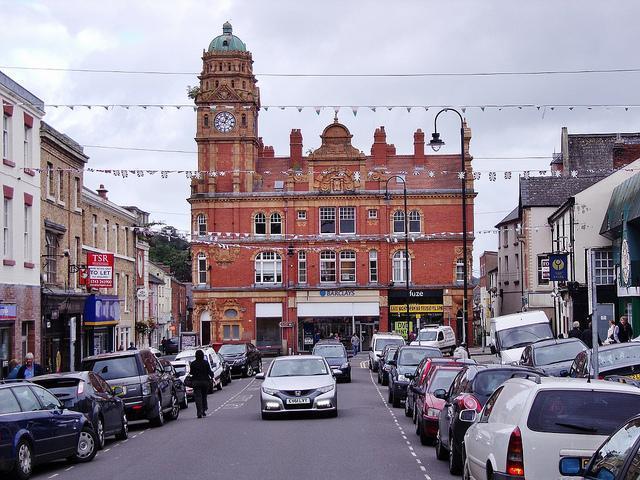How many cars are there?
Give a very brief answer. 9. 